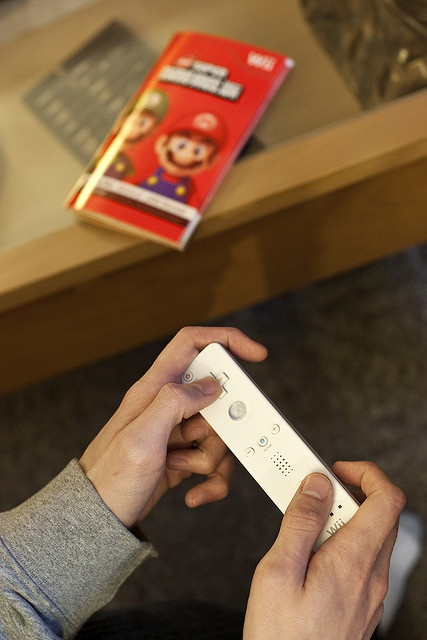Describe the objects in this image and their specific colors. I can see people in black, tan, and gray tones, book in black, red, brown, and tan tones, and remote in black, beige, tan, and darkgray tones in this image. 